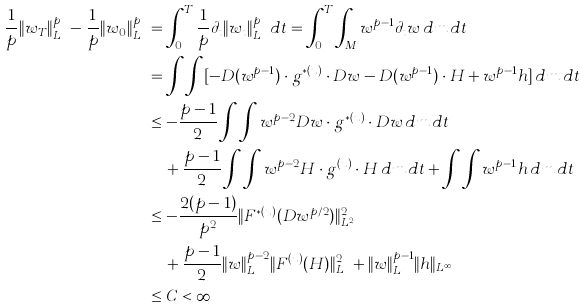Convert formula to latex. <formula><loc_0><loc_0><loc_500><loc_500>\frac { 1 } { p } \| w _ { T } \| _ { L ^ { p } } ^ { p } - \frac { 1 } { p } \| w _ { 0 } \| _ { L ^ { p } } ^ { p } & = \int _ { 0 } ^ { T } \frac { 1 } { p } \partial _ { t } \| w _ { t } \| _ { L ^ { p } } ^ { p } \, d t = \int _ { 0 } ^ { T } \int _ { M } w ^ { p - 1 } \partial _ { t } w \, d m \, d t \\ & = \int \int [ - D ( w ^ { p - 1 } ) \cdot g ^ { * ( u ) } \cdot D w - D ( w ^ { p - 1 } ) \cdot H + w ^ { p - 1 } h ] \, d m \, d t \\ & \leq - \frac { p - 1 } 2 \int \int w ^ { p - 2 } D w \cdot g ^ { * ( u ) } \cdot D w \, d m \, d t \\ & \quad + \frac { p - 1 } 2 \int \int w ^ { p - 2 } H \cdot g ^ { ( u ) } \cdot H \, d m \, d t + \int \int w ^ { p - 1 } h \, d m \, d t \\ & \leq - \frac { 2 ( p - 1 ) } { p ^ { 2 } } \| F ^ { * ( u ) } ( D w ^ { p / 2 } ) \| _ { L ^ { 2 } } ^ { 2 } \\ & \quad + \frac { p - 1 } 2 \| w \| _ { L ^ { p } } ^ { p - 2 } \| F ^ { ( u ) } ( H ) \| _ { L ^ { p } } ^ { 2 } + \| w \| _ { L ^ { p } } ^ { p - 1 } \| h \| _ { L ^ { \infty } } \\ & \leq C < \infty</formula> 